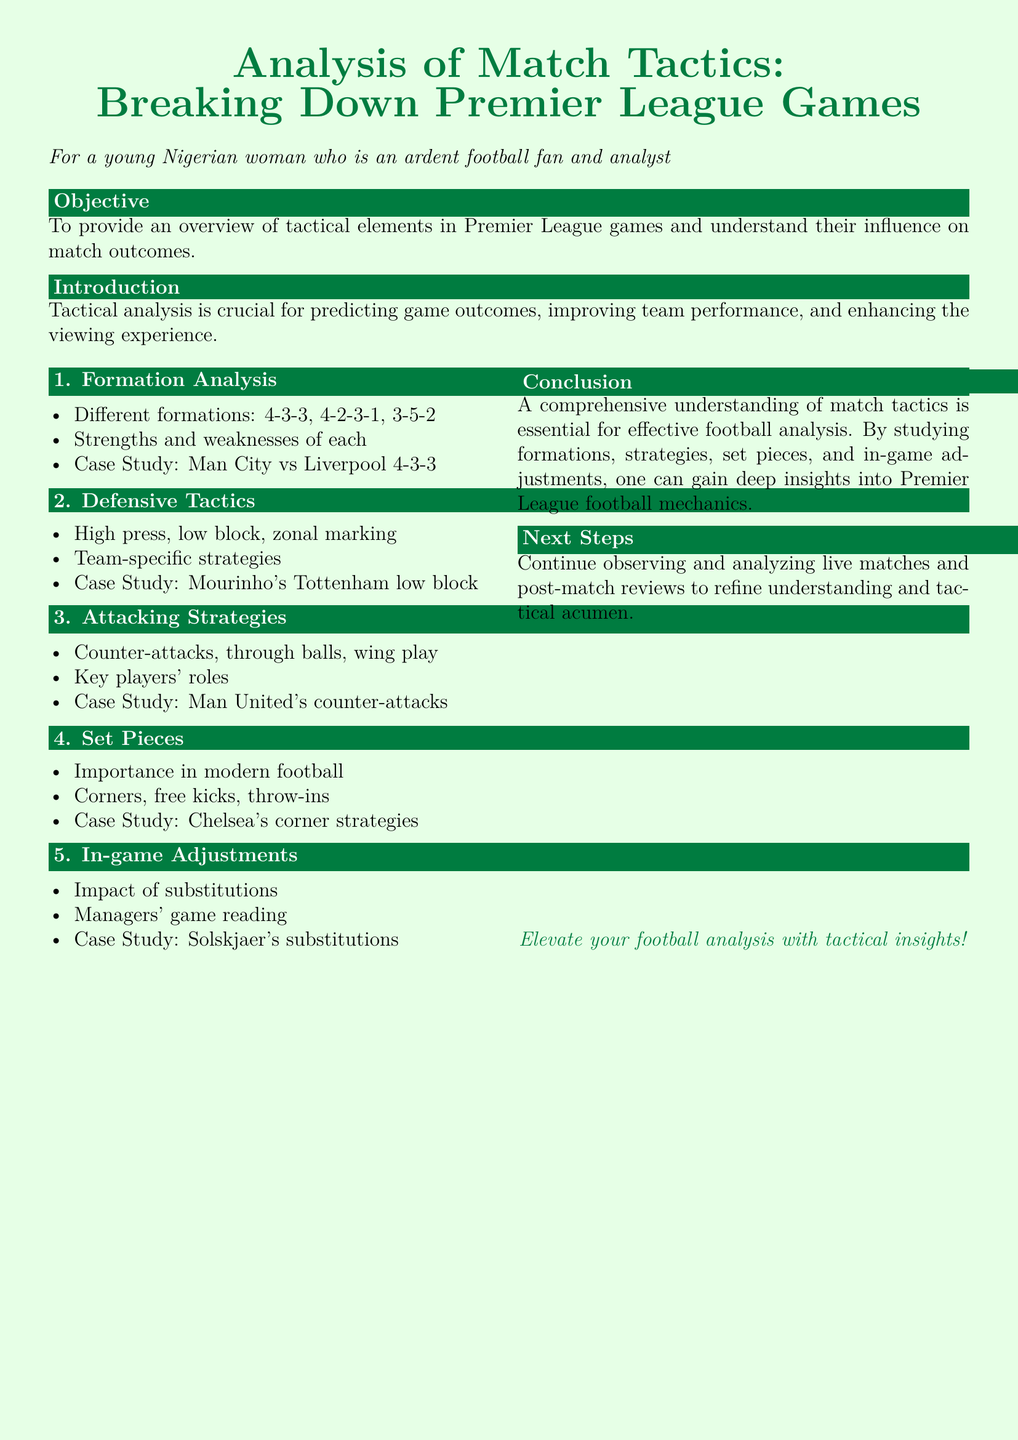What is the objective of the lesson plan? The objective is to provide an overview of tactical elements in Premier League games and understand their influence on match outcomes.
Answer: Overview of tactical elements What is a key attacking strategy mentioned in the document? The document lists several attacking strategies, including counter-attacks, through balls, and wing play.
Answer: Counter-attacks Which case study is associated with defensive tactics? The document specifies a case study focusing on Mourinho’s Tottenham low block.
Answer: Mourinho's Tottenham low block What are the three types of set pieces discussed? The document mentions corners, free kicks, and throw-ins as important set pieces.
Answer: Corners, free kicks, throw-ins Which formation is highlighted in the formation analysis section? The formation analysis section specifically references the 4-3-3 formation used by Man City vs Liverpool.
Answer: 4-3-3 What section discusses the impact of substitutions? The impact of substitutions is covered in the "In-game Adjustments" section of the document.
Answer: In-game Adjustments Who is the manager associated with the case study on substitutions? The document cites Solskjaer regarding his substitutions as a case study.
Answer: Solskjaer How many case studies are referenced in the document? There are four case studies mentioned in the lesson plan.
Answer: Four 